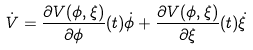Convert formula to latex. <formula><loc_0><loc_0><loc_500><loc_500>\dot { V } = \frac { \partial V ( \phi , \xi ) } { \partial \phi } ( t ) \dot { \phi } + \frac { \partial V ( \phi , \xi ) } { \partial \xi } ( t ) \dot { \xi }</formula> 